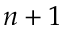Convert formula to latex. <formula><loc_0><loc_0><loc_500><loc_500>n + 1</formula> 